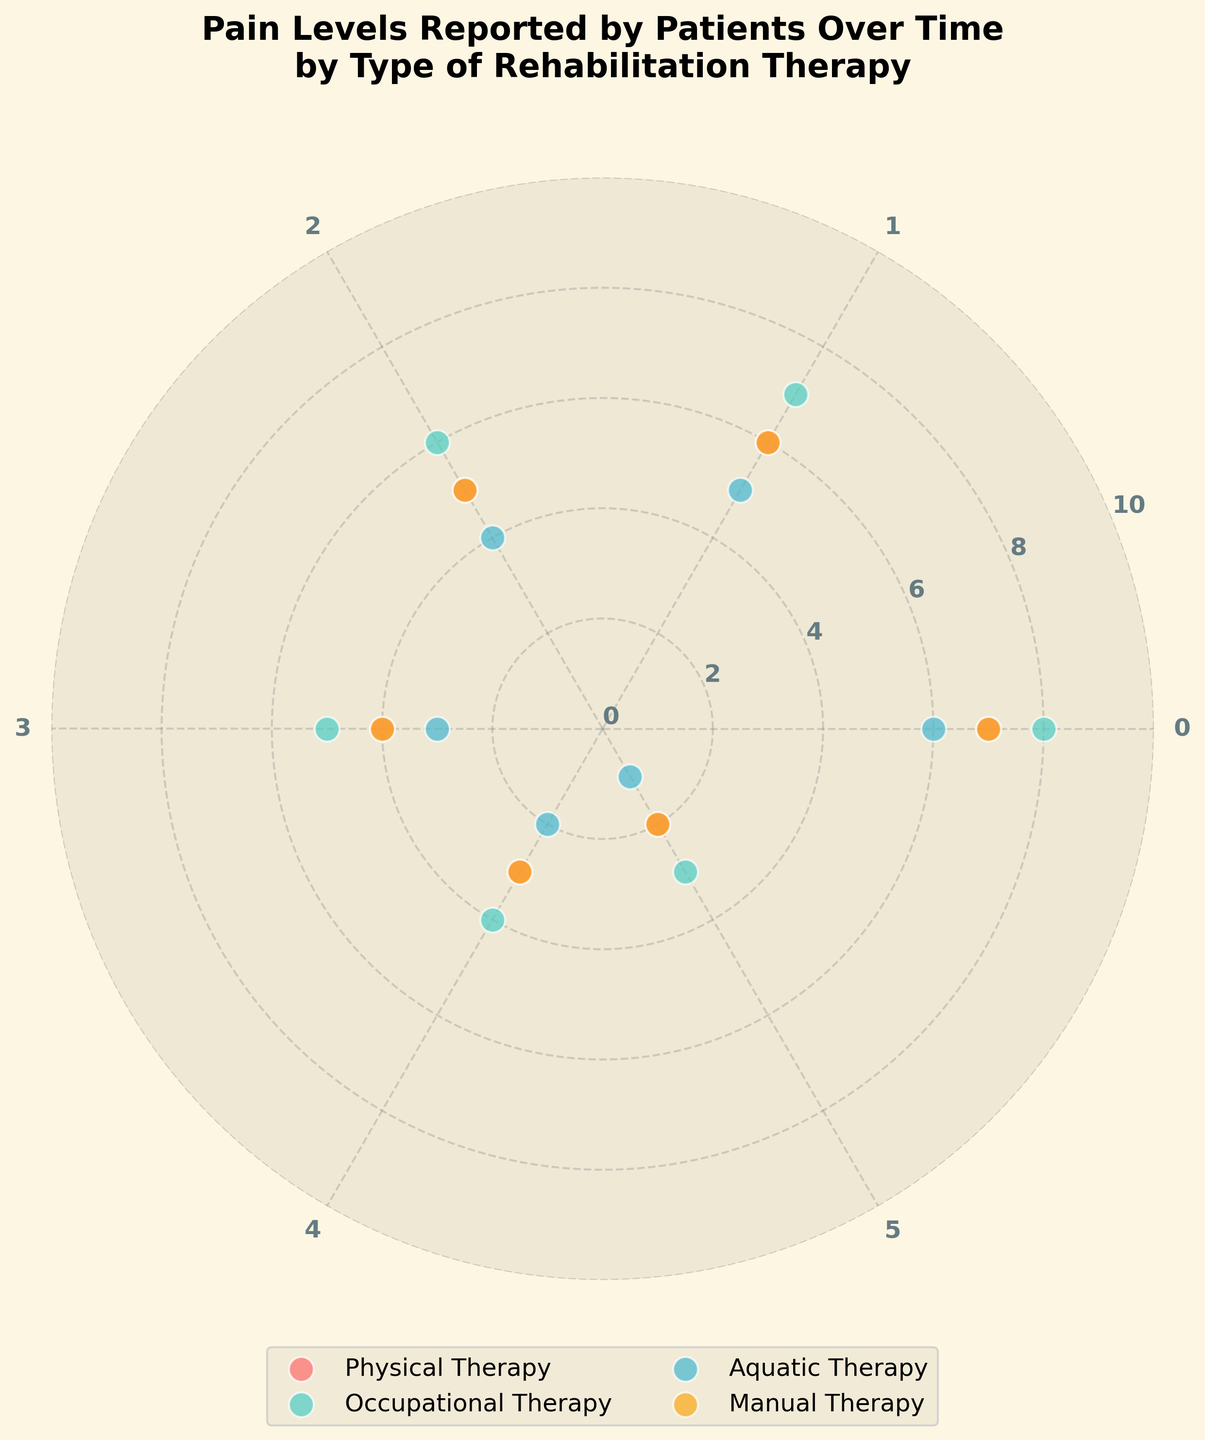What are the therapy types shown in the figure? The figure shows four different types of rehabilitation therapies. You can identify them by looking at the legend near the figure, which lists all therapy types represented by different colors.
Answer: Physical Therapy, Occupational Therapy, Aquatic Therapy, Manual Therapy Which therapy started with the highest reported pain level? By looking at the pain levels at timestamp 0, we can see that Occupational Therapy has the highest initial reported pain level of 8.
Answer: Occupational Therapy Which therapy type experienced the most significant reduction in reported pain levels over time? Compare the initial pain levels with the final pain levels for each therapy type. Physical Therapy goes from 7 to 2, Occupational Therapy goes from 8 to 3, Aquatic Therapy goes from 6 to 1, and Manual Therapy goes from 7 to 2. Aquatic Therapy has the most significant reduction from 6 to 1 (5 units).
Answer: Aquatic Therapy At timestamp 3, which therapy had the lowest reported pain level? At timestamp 3, inspect the radial position for each therapy type. Aquatic Therapy shows a pain level of 3, which is the lowest among the therapy types at this timestamp.
Answer: Aquatic Therapy How do pain levels change over time for Manual Therapy? Observing Manual Therapy at timestamps 0 through 5, the pain levels go from 7, 6, 5, 4, 3, to 2, indicating a consistent decrease over time.
Answer: Decrease over time Which two therapies had the same pain level at timestamp 0? At timestamp 0, Physical Therapy and Manual Therapy both reported a pain level of 7. This can be seen by inspecting the radial positions for timestamp 0.
Answer: Physical Therapy and Manual Therapy What is the purple-colored therapy's pain level at timestamp 1? Note the color coding in the legend: Aquatic Therapy is represented in purple. At timestamp 1, the radial position for Aquatic Therapy shows a pain level of 5.
Answer: 5 Which therapy had a pain level of 2 at some point during the observations, and at which timestamp? From the polar scatter plot, we look for data points at radial position 2. Physical Therapy showed a pain level of 2 at timestamp 5, and Manual Therapy showed a pain level of 2 at timestamp 5.
Answer: Physical Therapy and Manual Therapy at timestamp 5 Between timestamps 2 and 4, which therapy showed the least reduction in pain level? Calculate the difference in pain levels from timestamps 2 to 4 for each therapy: Physical Therapy (5 to 3: 2), Occupational Therapy (6 to 4: 2), Aquatic Therapy (4 to 2: 2), and Manual Therapy (5 to 3: 2). All therapies show the same reduction of 2 units.
Answer: All therapies (same reduction of 2 units) 